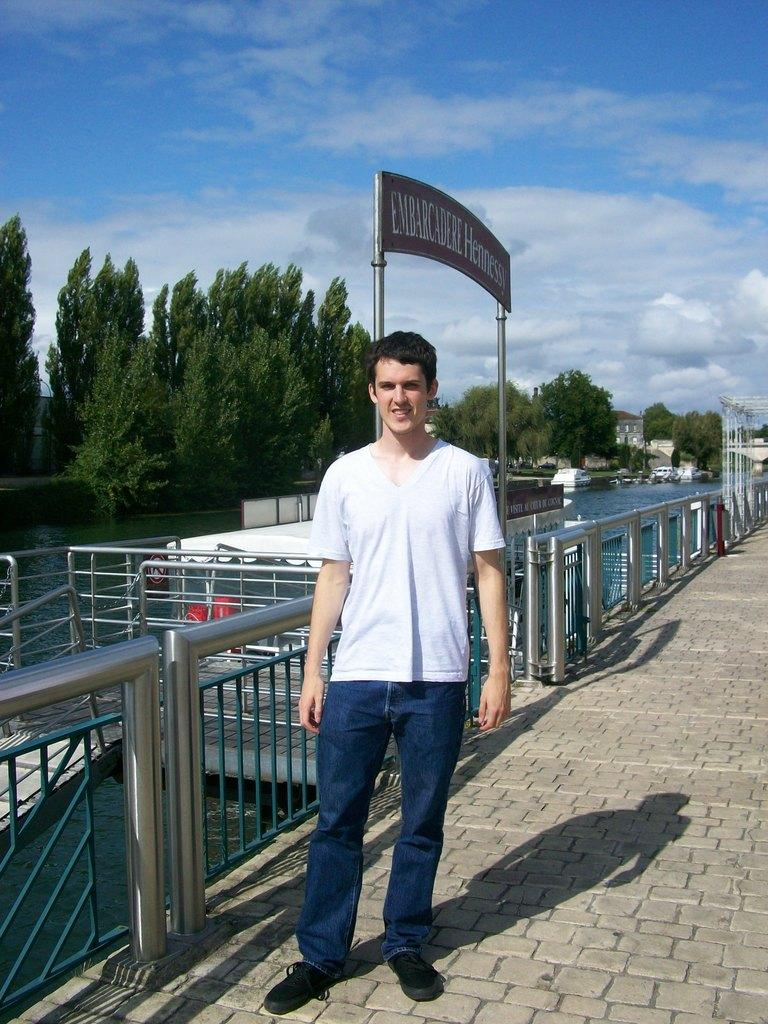What is the main feature of the image? The main feature of the image is a water surface. What is located near the water surface? There is a bridge beside the water surface. Is there anyone on the bridge? Yes, a person is standing on the bridge. What can be seen on the left side of the image? There are many trees on the left side of the image. How many turkeys are visible in the image? There are no turkeys present in the image. What type of machine is being used by the person on the bridge? There is no machine visible in the image, and the person on the bridge is not using any machine. 